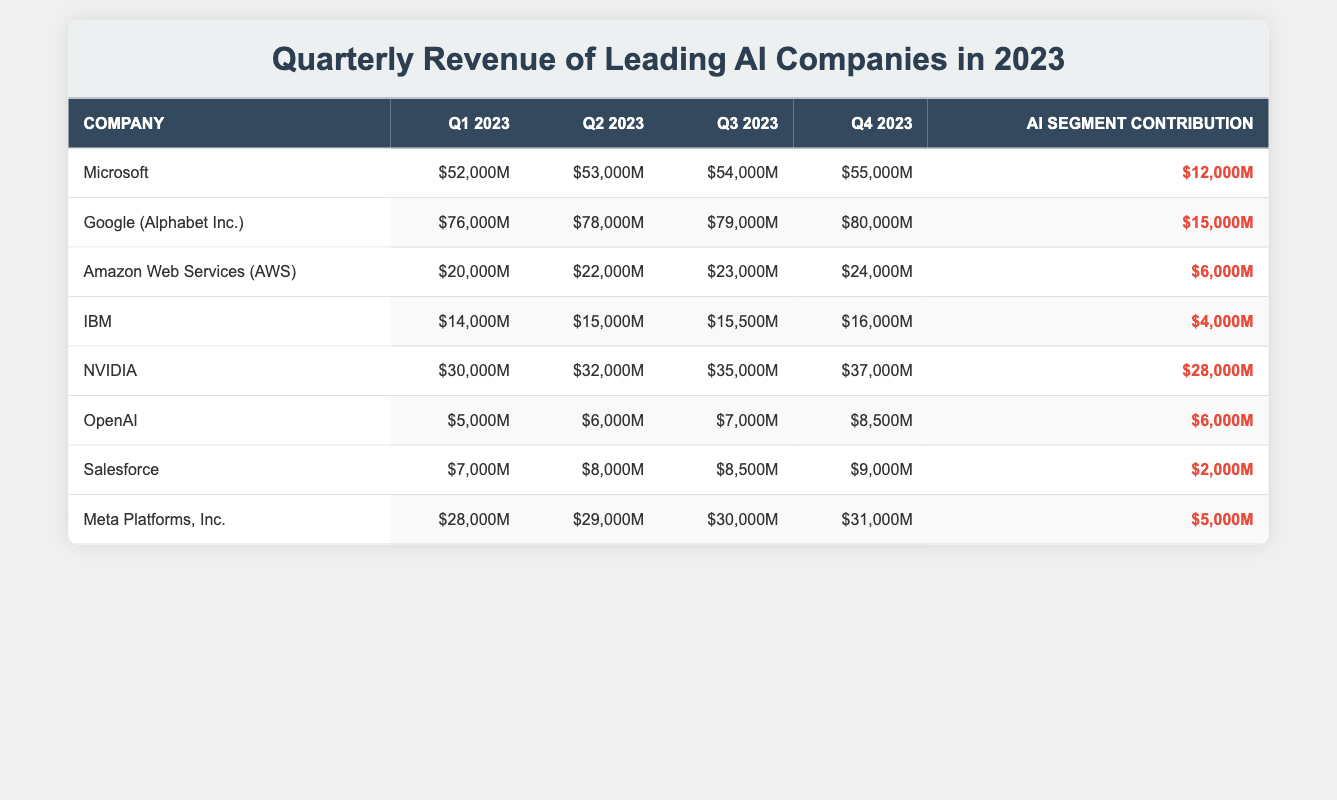What is the total revenue of Microsoft in Q4 2023? The revenue for Microsoft in Q4 2023 is listed as $55,000 million in the table.
Answer: $55,000 million Which company had the largest AI segment contribution in 2023? The table shows that NVIDIA had the largest AI segment contribution at $28,000 million.
Answer: NVIDIA How much did Google earn in Q1 2023? According to the table, Google earned $76,000 million in Q1 2023.
Answer: $76,000 million What is the average Q3 revenue for the listed companies? Adding the Q3 revenues: 54,000 (Microsoft) + 79,000 (Google) + 23,000 (AWS) + 15,500 (IBM) + 35,000 (NVIDIA) + 7,000 (OpenAI) + 8,500 (Salesforce) + 30,000 (Meta) = 252,000 million. There are 8 companies, so the average is 252,000 / 8 = 31,500 million.
Answer: $31,500 million Did Amazon Web Services have a higher AI segment contribution than Salesforce? AWS had an AI segment contribution of $6,000 million while Salesforce had $2,000 million. Since 6,000 is greater than 2,000, the statement is true.
Answer: Yes What is the difference in revenue between NVIDIA and IBM in Q2 2023? In Q2 2023, NVIDIA earned $32,000 million and IBM earned $15,000 million. The difference is 32,000 - 15,000 = 17,000 million.
Answer: $17,000 million Which company's total revenue for the four quarters is the highest? Summing the revenues: Microsoft (2 Q's: 52,000 + 53,000 + 54,000 + 55,000 = 214,000), Google (4 Q's: 76,000 + 78,000 + 79,000 + 80,000 = 313,000), NVIDIA (4 Q's: 30,000 + 32,000 + 35,000 + 37,000 = 134,000), among others, Google has the highest total revenue of 313,000 million.
Answer: Google What was the total AI segment contribution from all companies in 2023? Adding the contributions: 12,000 (Microsoft) + 15,000 (Google) + 6,000 (AWS) + 4,000 (IBM) + 28,000 (NVIDIA) + 6,000 (OpenAI) + 2,000 (Salesforce) + 5,000 (Meta) = 78,000 million.
Answer: $78,000 million Is the Q4 revenue for Meta Platforms is more than that of OpenAI? Meta reported $31,000 million for Q4 while OpenAI reported $8,500 million. 31,000 is greater than 8,500, making the statement true.
Answer: Yes Who had the lowest Q1 revenue among the companies listed? Comparing Q1 revenues, OpenAI at $5,000 million had the lowest.
Answer: OpenAI 